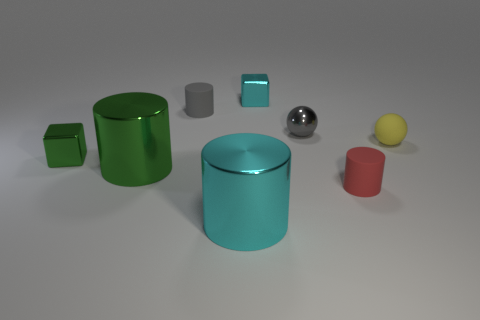Can you tell me about the colors and shapes of the objects in this image? Certainly! The image displays a collection of objects with various colors and shapes. We see cylinders in green and cyan, cubes in green and grey, a sphere in silver, and a small sphere in yellow. The diversity of geometrical forms and colors makes this a visually interesting setup. 